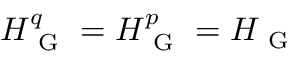<formula> <loc_0><loc_0><loc_500><loc_500>H _ { G } ^ { q } = H _ { G } ^ { p } = H _ { G }</formula> 